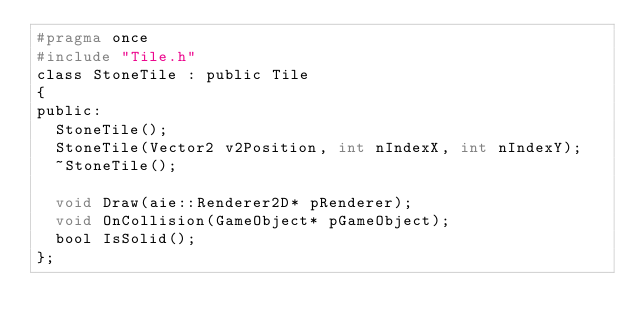<code> <loc_0><loc_0><loc_500><loc_500><_C_>#pragma once
#include "Tile.h"
class StoneTile : public Tile
{
public:
	StoneTile();
	StoneTile(Vector2 v2Position, int nIndexX, int nIndexY);
	~StoneTile();

	void Draw(aie::Renderer2D* pRenderer);
	void OnCollision(GameObject* pGameObject);
	bool IsSolid();
};

</code> 